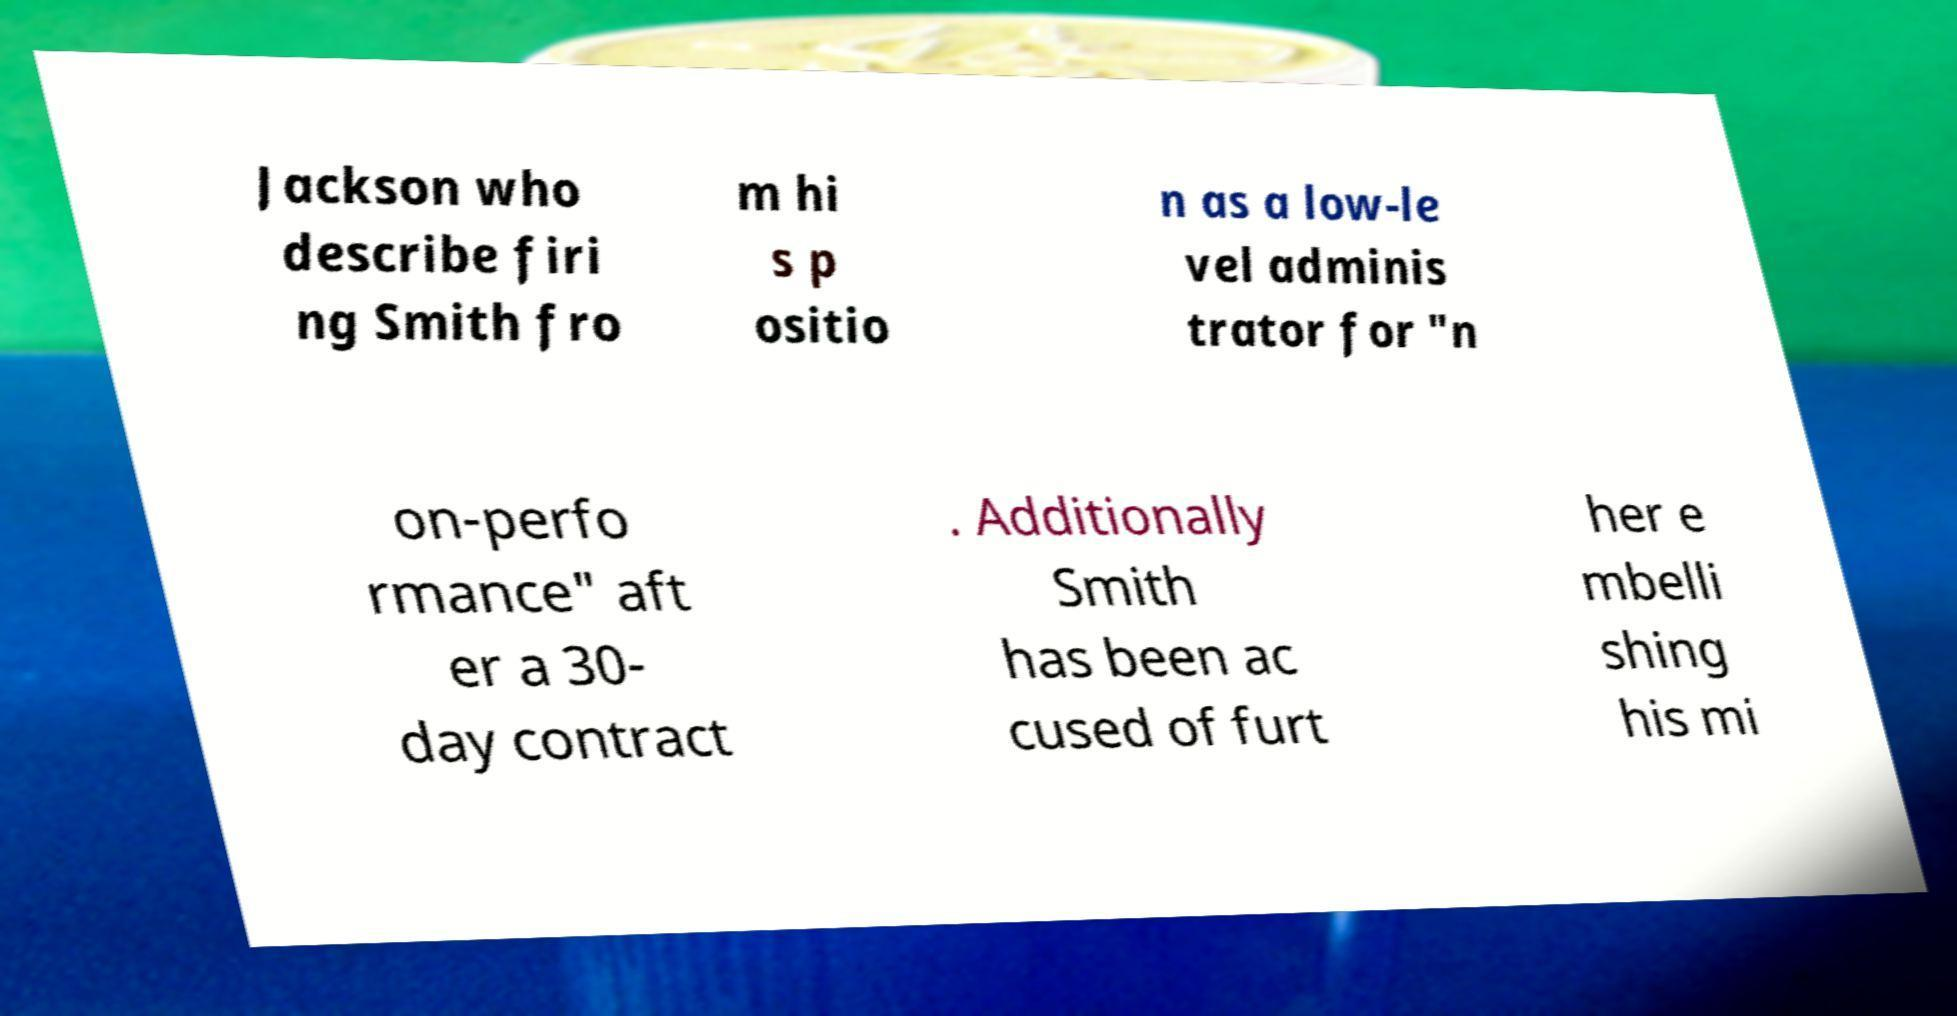Can you accurately transcribe the text from the provided image for me? Jackson who describe firi ng Smith fro m hi s p ositio n as a low-le vel adminis trator for "n on-perfo rmance" aft er a 30- day contract . Additionally Smith has been ac cused of furt her e mbelli shing his mi 